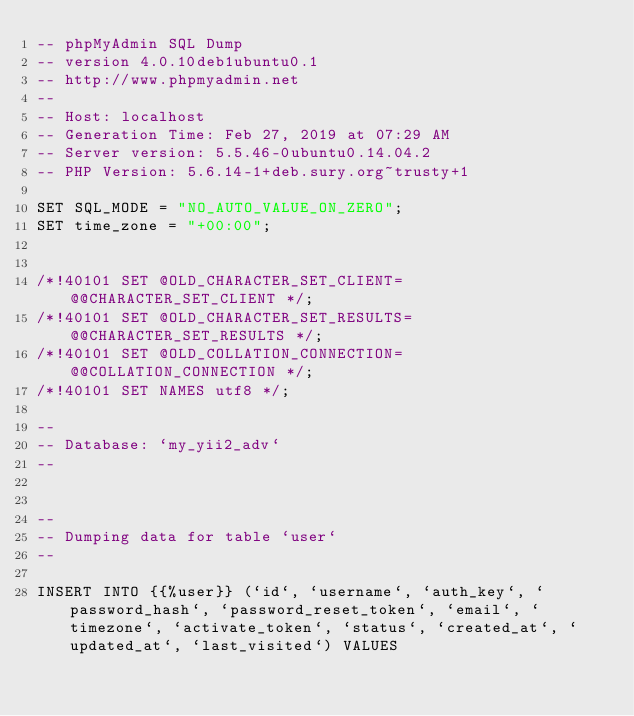Convert code to text. <code><loc_0><loc_0><loc_500><loc_500><_SQL_>-- phpMyAdmin SQL Dump
-- version 4.0.10deb1ubuntu0.1
-- http://www.phpmyadmin.net
--
-- Host: localhost
-- Generation Time: Feb 27, 2019 at 07:29 AM
-- Server version: 5.5.46-0ubuntu0.14.04.2
-- PHP Version: 5.6.14-1+deb.sury.org~trusty+1

SET SQL_MODE = "NO_AUTO_VALUE_ON_ZERO";
SET time_zone = "+00:00";


/*!40101 SET @OLD_CHARACTER_SET_CLIENT=@@CHARACTER_SET_CLIENT */;
/*!40101 SET @OLD_CHARACTER_SET_RESULTS=@@CHARACTER_SET_RESULTS */;
/*!40101 SET @OLD_COLLATION_CONNECTION=@@COLLATION_CONNECTION */;
/*!40101 SET NAMES utf8 */;

--
-- Database: `my_yii2_adv`
--


--
-- Dumping data for table `user`
--

INSERT INTO {{%user}} (`id`, `username`, `auth_key`, `password_hash`, `password_reset_token`, `email`, `timezone`, `activate_token`, `status`, `created_at`, `updated_at`, `last_visited`) VALUES</code> 